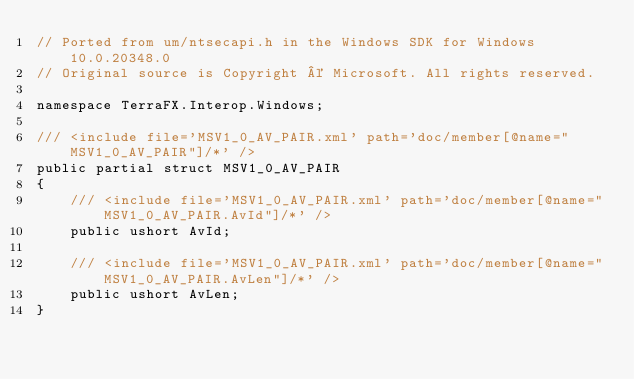Convert code to text. <code><loc_0><loc_0><loc_500><loc_500><_C#_>// Ported from um/ntsecapi.h in the Windows SDK for Windows 10.0.20348.0
// Original source is Copyright © Microsoft. All rights reserved.

namespace TerraFX.Interop.Windows;

/// <include file='MSV1_0_AV_PAIR.xml' path='doc/member[@name="MSV1_0_AV_PAIR"]/*' />
public partial struct MSV1_0_AV_PAIR
{
    /// <include file='MSV1_0_AV_PAIR.xml' path='doc/member[@name="MSV1_0_AV_PAIR.AvId"]/*' />
    public ushort AvId;

    /// <include file='MSV1_0_AV_PAIR.xml' path='doc/member[@name="MSV1_0_AV_PAIR.AvLen"]/*' />
    public ushort AvLen;
}
</code> 